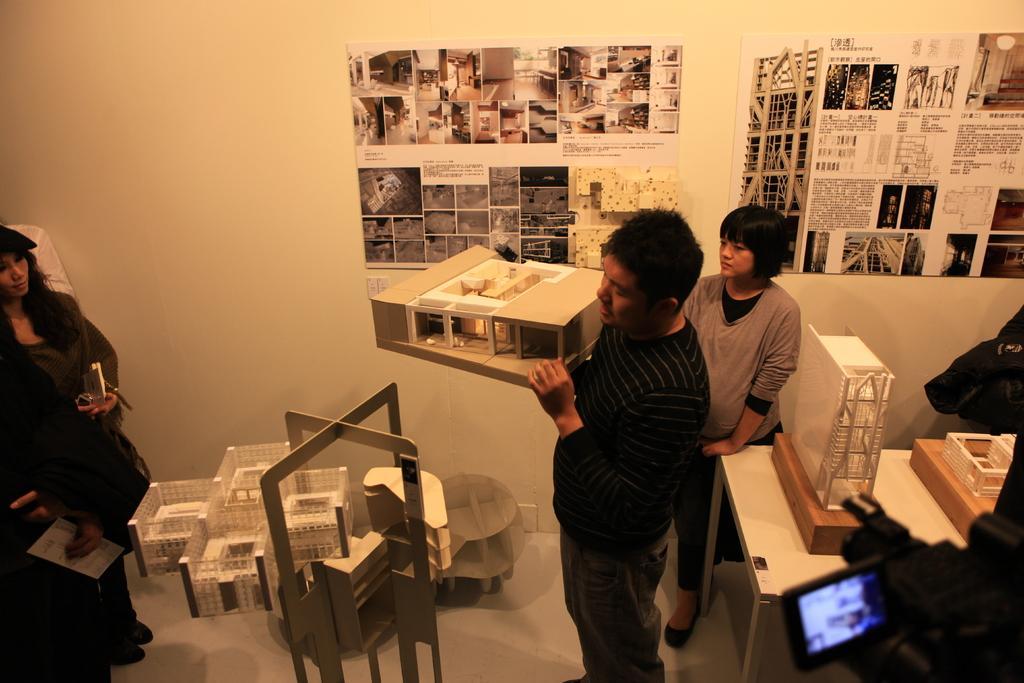Could you give a brief overview of what you see in this image? In this picture we can see a three people standing one is woman and two are men, a woman is holding something the hand and in the background we can see a white wall and some pictures and photos are passed to it and just beside to it there is another table and some construction site are shown on that, and we can also see some camera screen near to the table. 